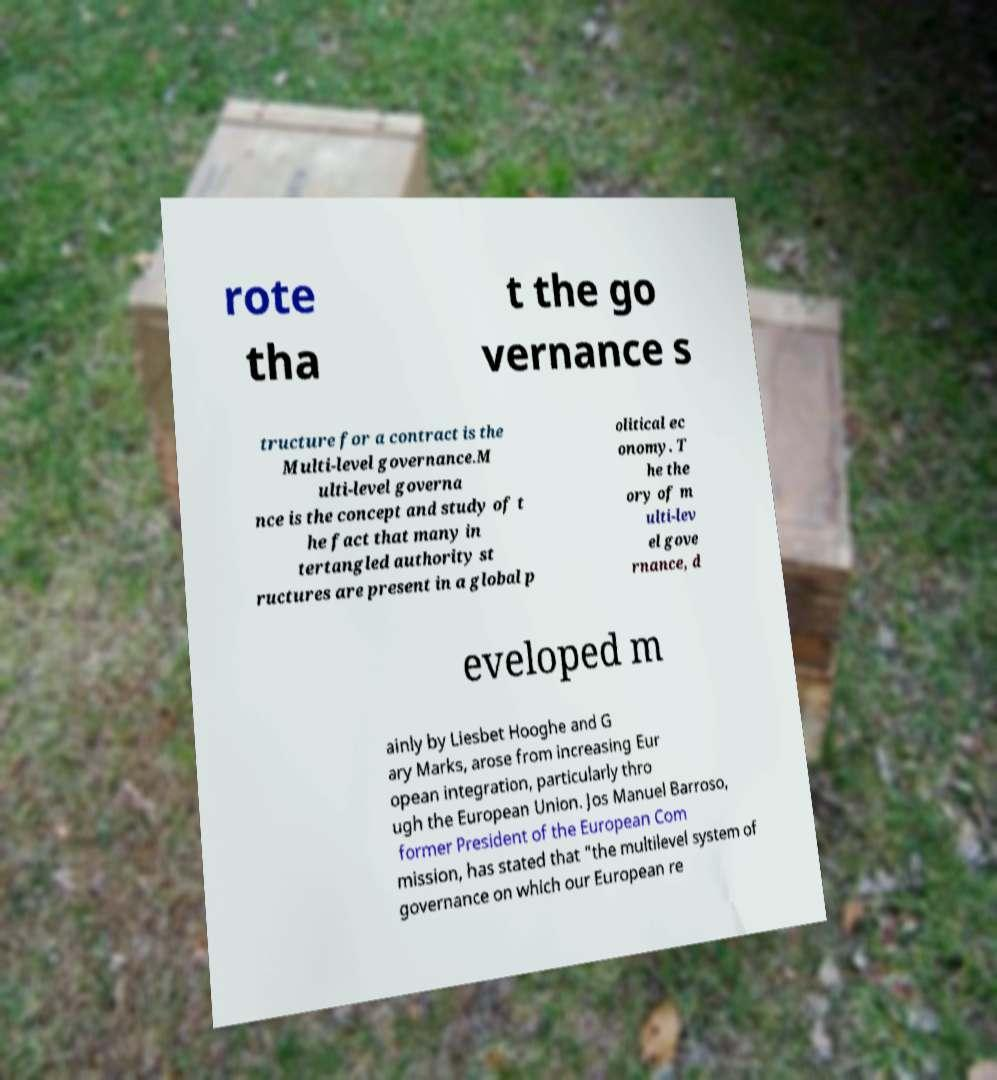Please identify and transcribe the text found in this image. rote tha t the go vernance s tructure for a contract is the Multi-level governance.M ulti-level governa nce is the concept and study of t he fact that many in tertangled authority st ructures are present in a global p olitical ec onomy. T he the ory of m ulti-lev el gove rnance, d eveloped m ainly by Liesbet Hooghe and G ary Marks, arose from increasing Eur opean integration, particularly thro ugh the European Union. Jos Manuel Barroso, former President of the European Com mission, has stated that "the multilevel system of governance on which our European re 